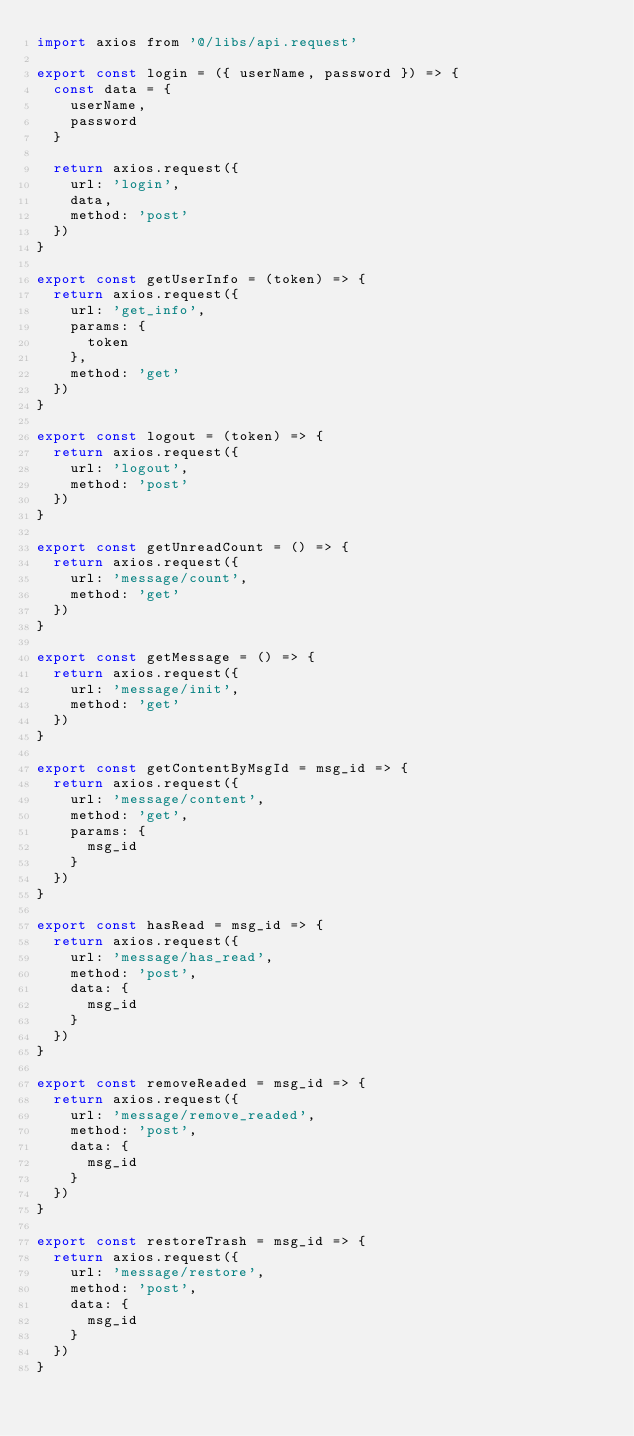<code> <loc_0><loc_0><loc_500><loc_500><_JavaScript_>import axios from '@/libs/api.request'

export const login = ({ userName, password }) => {
  const data = {
    userName,
    password
  }

  return axios.request({
    url: 'login',
    data,
    method: 'post'
  })
}

export const getUserInfo = (token) => {
  return axios.request({
    url: 'get_info',
    params: {
      token
    },
    method: 'get'
  })
}

export const logout = (token) => {
  return axios.request({
    url: 'logout',
    method: 'post'
  })
}

export const getUnreadCount = () => {
  return axios.request({
    url: 'message/count',
    method: 'get'
  })
}

export const getMessage = () => {
  return axios.request({
    url: 'message/init',
    method: 'get'
  })
}

export const getContentByMsgId = msg_id => {
  return axios.request({
    url: 'message/content',
    method: 'get',
    params: {
      msg_id
    }
  })
}

export const hasRead = msg_id => {
  return axios.request({
    url: 'message/has_read',
    method: 'post',
    data: {
      msg_id
    }
  })
}

export const removeReaded = msg_id => {
  return axios.request({
    url: 'message/remove_readed',
    method: 'post',
    data: {
      msg_id
    }
  })
}

export const restoreTrash = msg_id => {
  return axios.request({
    url: 'message/restore',
    method: 'post',
    data: {
      msg_id
    }
  })
}
</code> 